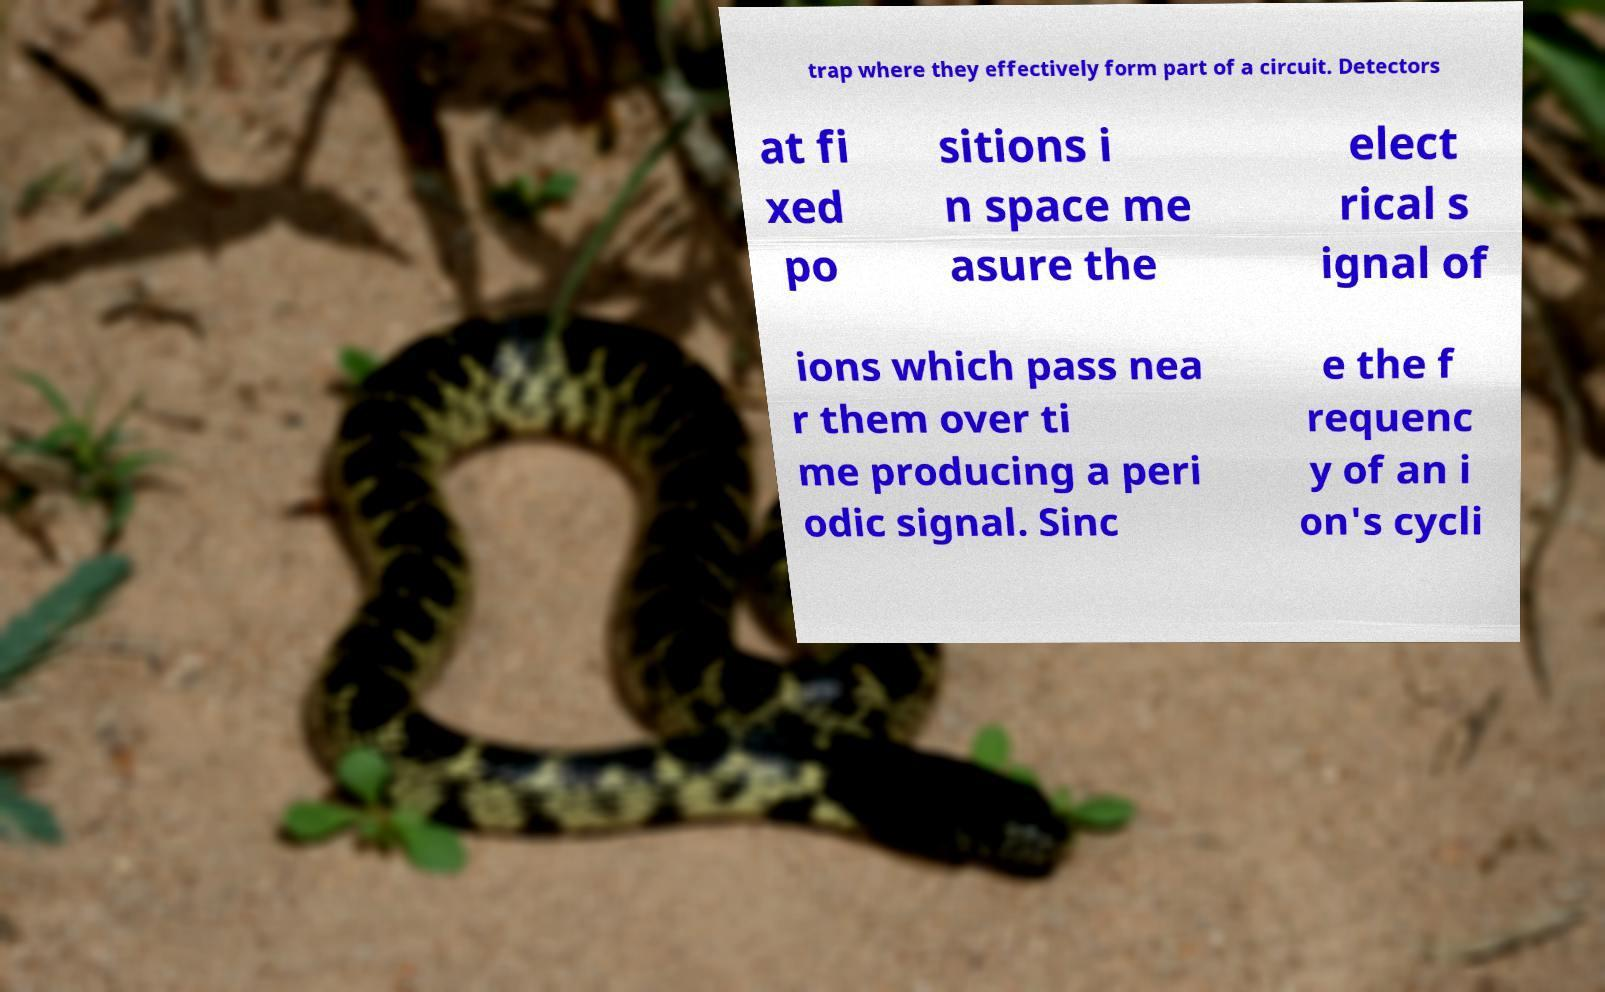Could you assist in decoding the text presented in this image and type it out clearly? trap where they effectively form part of a circuit. Detectors at fi xed po sitions i n space me asure the elect rical s ignal of ions which pass nea r them over ti me producing a peri odic signal. Sinc e the f requenc y of an i on's cycli 